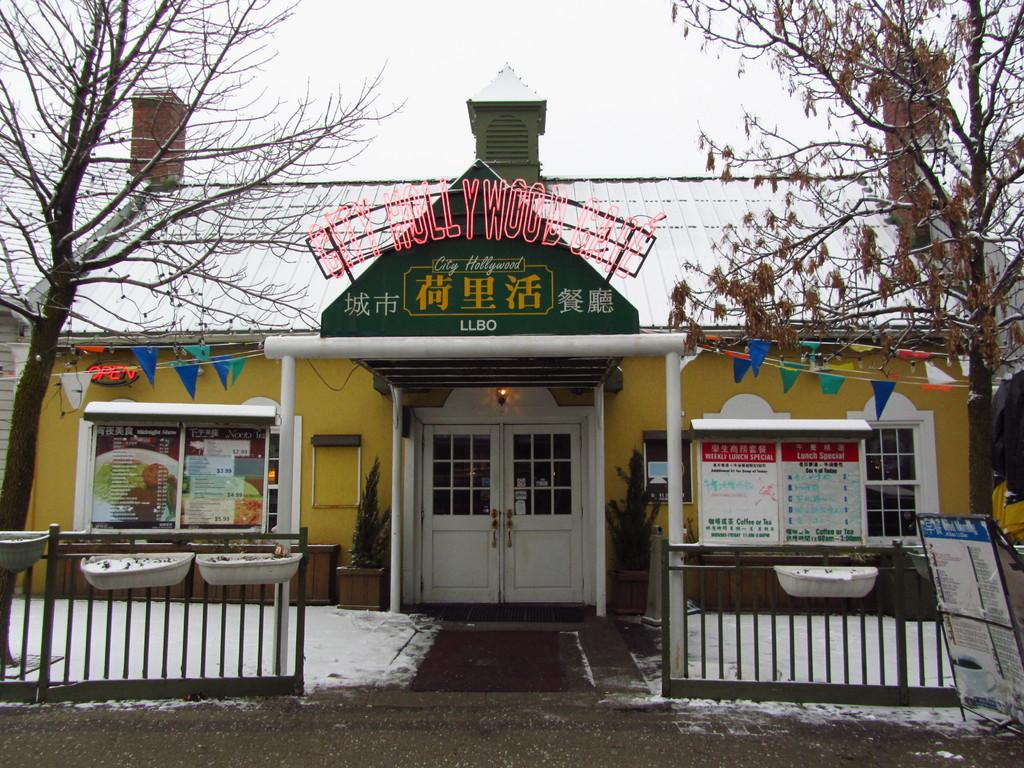What type of structure is visible in the image? There is a house in the image. What part of the house can be used for entering or exiting? There is a door in the image. What material is used to cover the walls of the house? There are boards in the image. What type of decorations are present on the walls of the house? There are posters in the image. What type of symbol or emblem can be seen in the image? There are flags in the image. What part of the house allows for natural light and ventilation? There are windows in the image. What type of vegetation is present in the image? There are plants in the image. What type of barrier surrounds the property in the image? There is a fence in the image. What type of tall vegetation is visible in the background of the image? There are trees in the image. What part of the natural environment is visible in the background of the image? The sky is visible in the background of the image. Where is the hat located in the image? There is no hat present in the image. What type of geological formation can be seen in the background of the image? There are no mountains visible in the image; only trees and the sky are present in the background. What type of appliance is used for washing dishes in the image? There is no sink present in the image. 